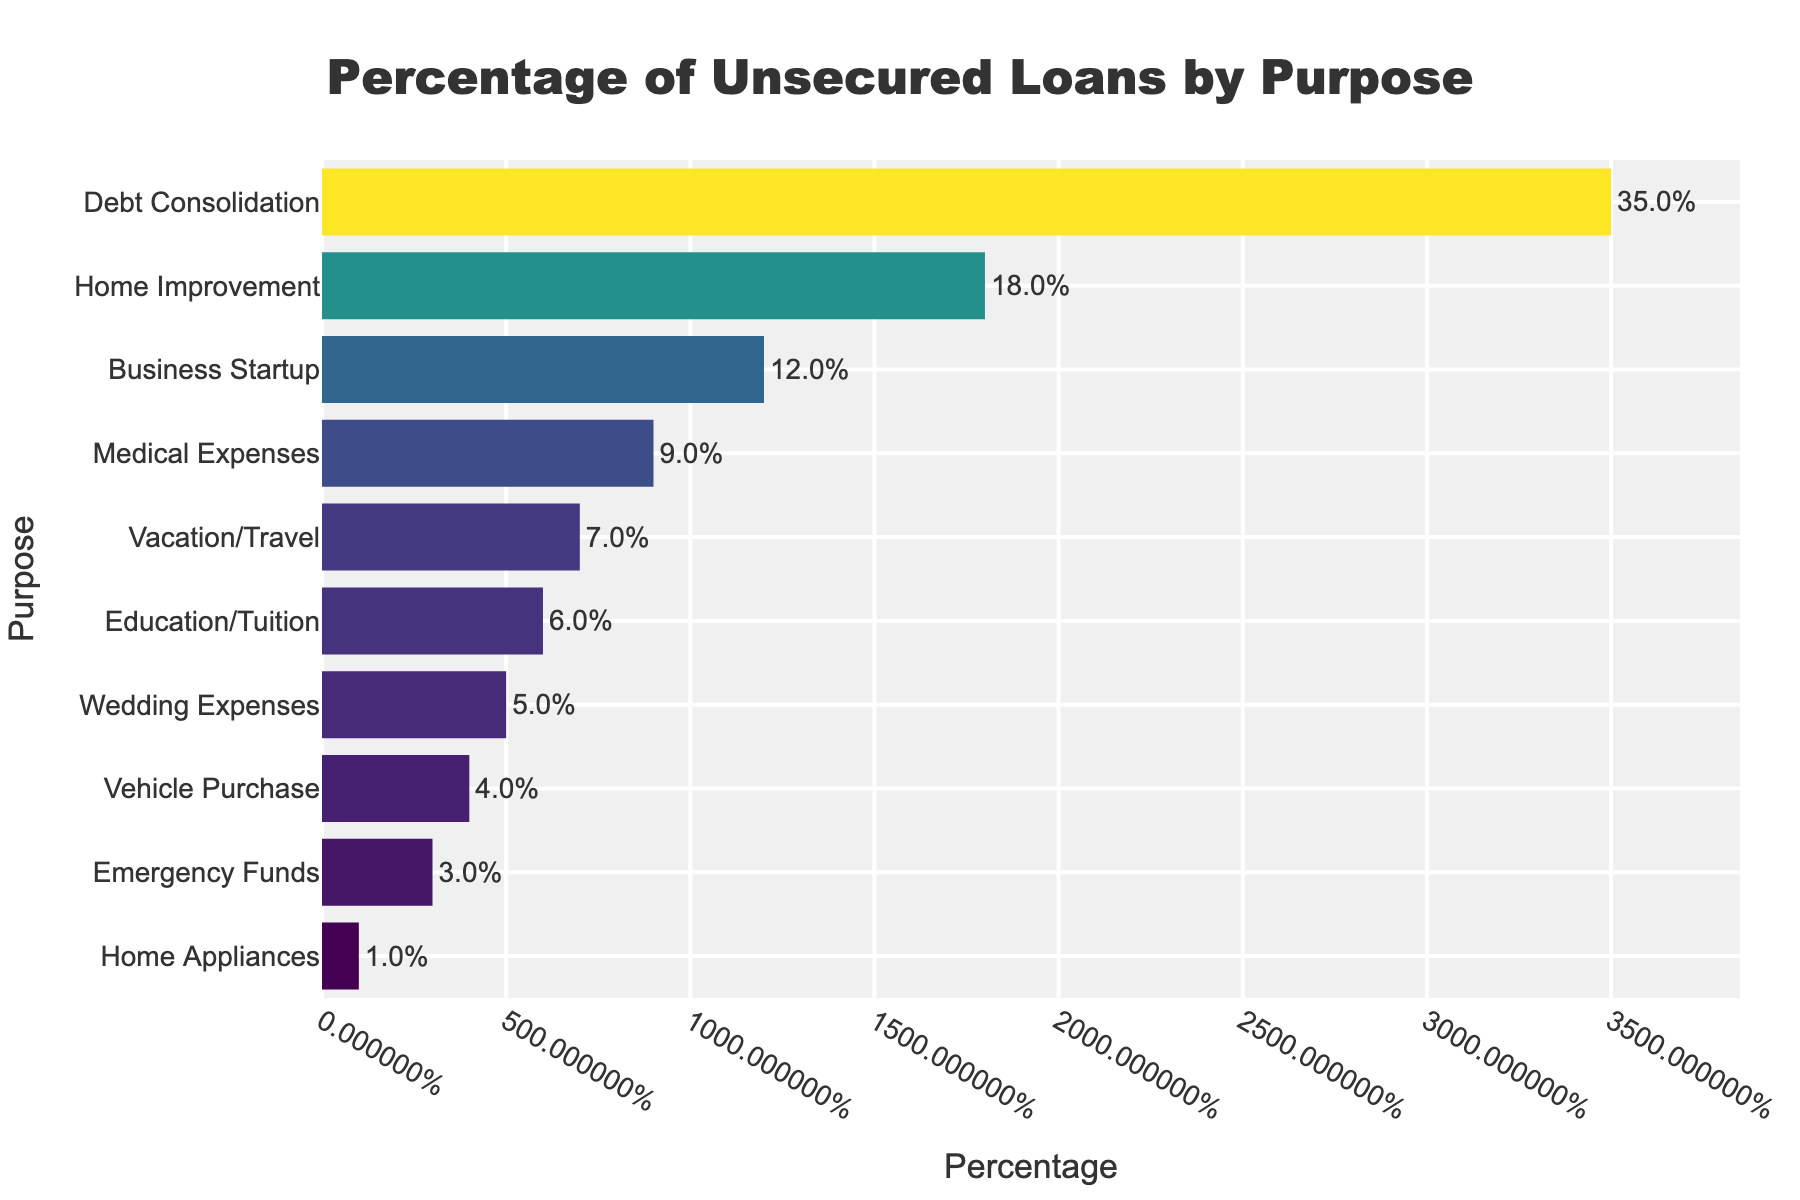Which purpose accounts for the highest percentage of unsecured loans? The bar corresponding to "Debt Consolidation" is the longest and appears at the top, indicating it has the highest percentage.
Answer: Debt Consolidation What is the total percentage of unsecured loans used for education/tuition and wedding expenses combined? Adding the percentages for Education/Tuition (6%) and Wedding Expenses (5%) gives: 6% + 5% = 11%
Answer: 11% How much more is the percentage for debt consolidation compared to medical expenses? The percentage for Debt Consolidation is 35%, and Medical Expenses is 9%. Subtracting these gives: 35% - 9% = 26%
Answer: 26% Which category uses a larger percentage of unsecured loans: home improvement or business startup? Comparing the lengths of the bars, the bar for Home Improvement (18%) is longer than the bar for Business Startup (12%).
Answer: Home Improvement What is the percentage difference between vacation/travel and vehicle purchase loans? The percentage for Vacation/Travel is 7%, and for Vehicle Purchase is 4%. Subtracting these gives: 7% - 4% = 3%
Answer: 3% Which category has the smallest percentage of unsecured loans? The shortest bar corresponds to "Home Appliances," indicating it has the smallest percentage.
Answer: Home Appliances By how much does the percentage for emergency funds differ from that for home appliances? Emergency Funds is at 3% and Home Appliances is at 1%. Subtracting these gives: 3% - 1% = 2%
Answer: 2% What is the combined percentage for business startup, medical expenses, and vacation/travel loans? Adding the percentages for Business Startup (12%), Medical Expenses (9%), and Vacation/Travel (7%) gives: 12% + 9% + 7% = 28%
Answer: 28% Are home improvement loans more or less than double the percentage of vehicle purchase loans? The percentage for Home Improvement is 18%, and for Vehicle Purchase is 4%. Doubling Vehicle Purchase, we get: 4% * 2 = 8%, and since 18% > 8%, home improvement loans are more than double.
Answer: More What is the average percentage of unsecured loans for debt consolidation, home improvement, and business startup? Averages are calculated by summing the percentages and dividing by the number of categories: (35% + 18% + 12%) / 3 = 65% / 3 ≈ 21.67%
Answer: 21.67% 